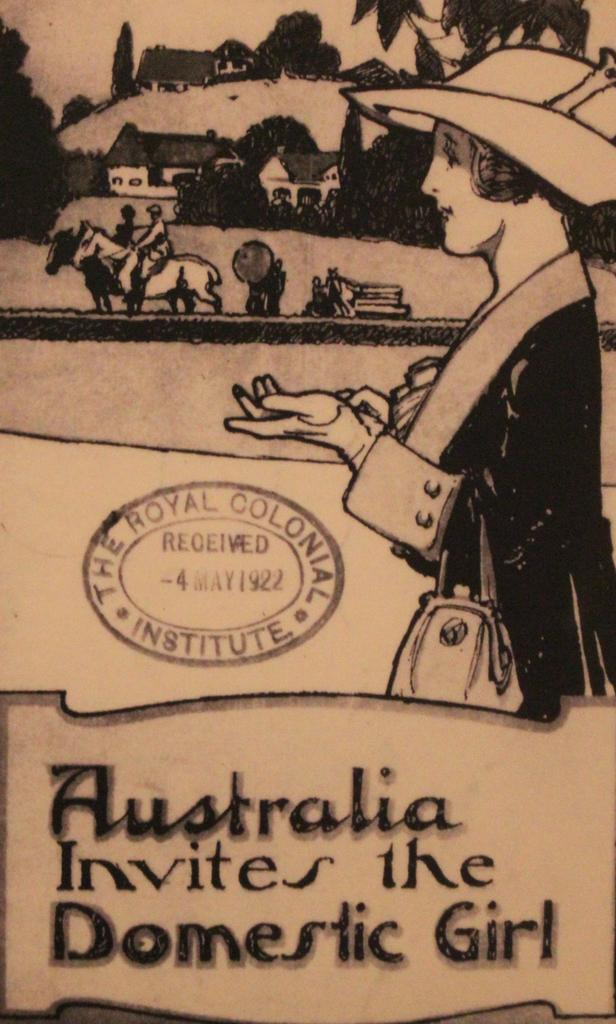What type of drawings can be seen in the image? There are drawings of a person, houses, and trees in the image. Are there any drawings of people interacting with animals or objects? Yes, there are drawings of persons sitting on animals or objects in the image. What else is present in the image besides the drawings? There are texts written on a board and a stamp in the image. What type of leather is used to create the fold in the image? There is no leather or fold present in the image; it consists of drawings, texts, and a stamp. 